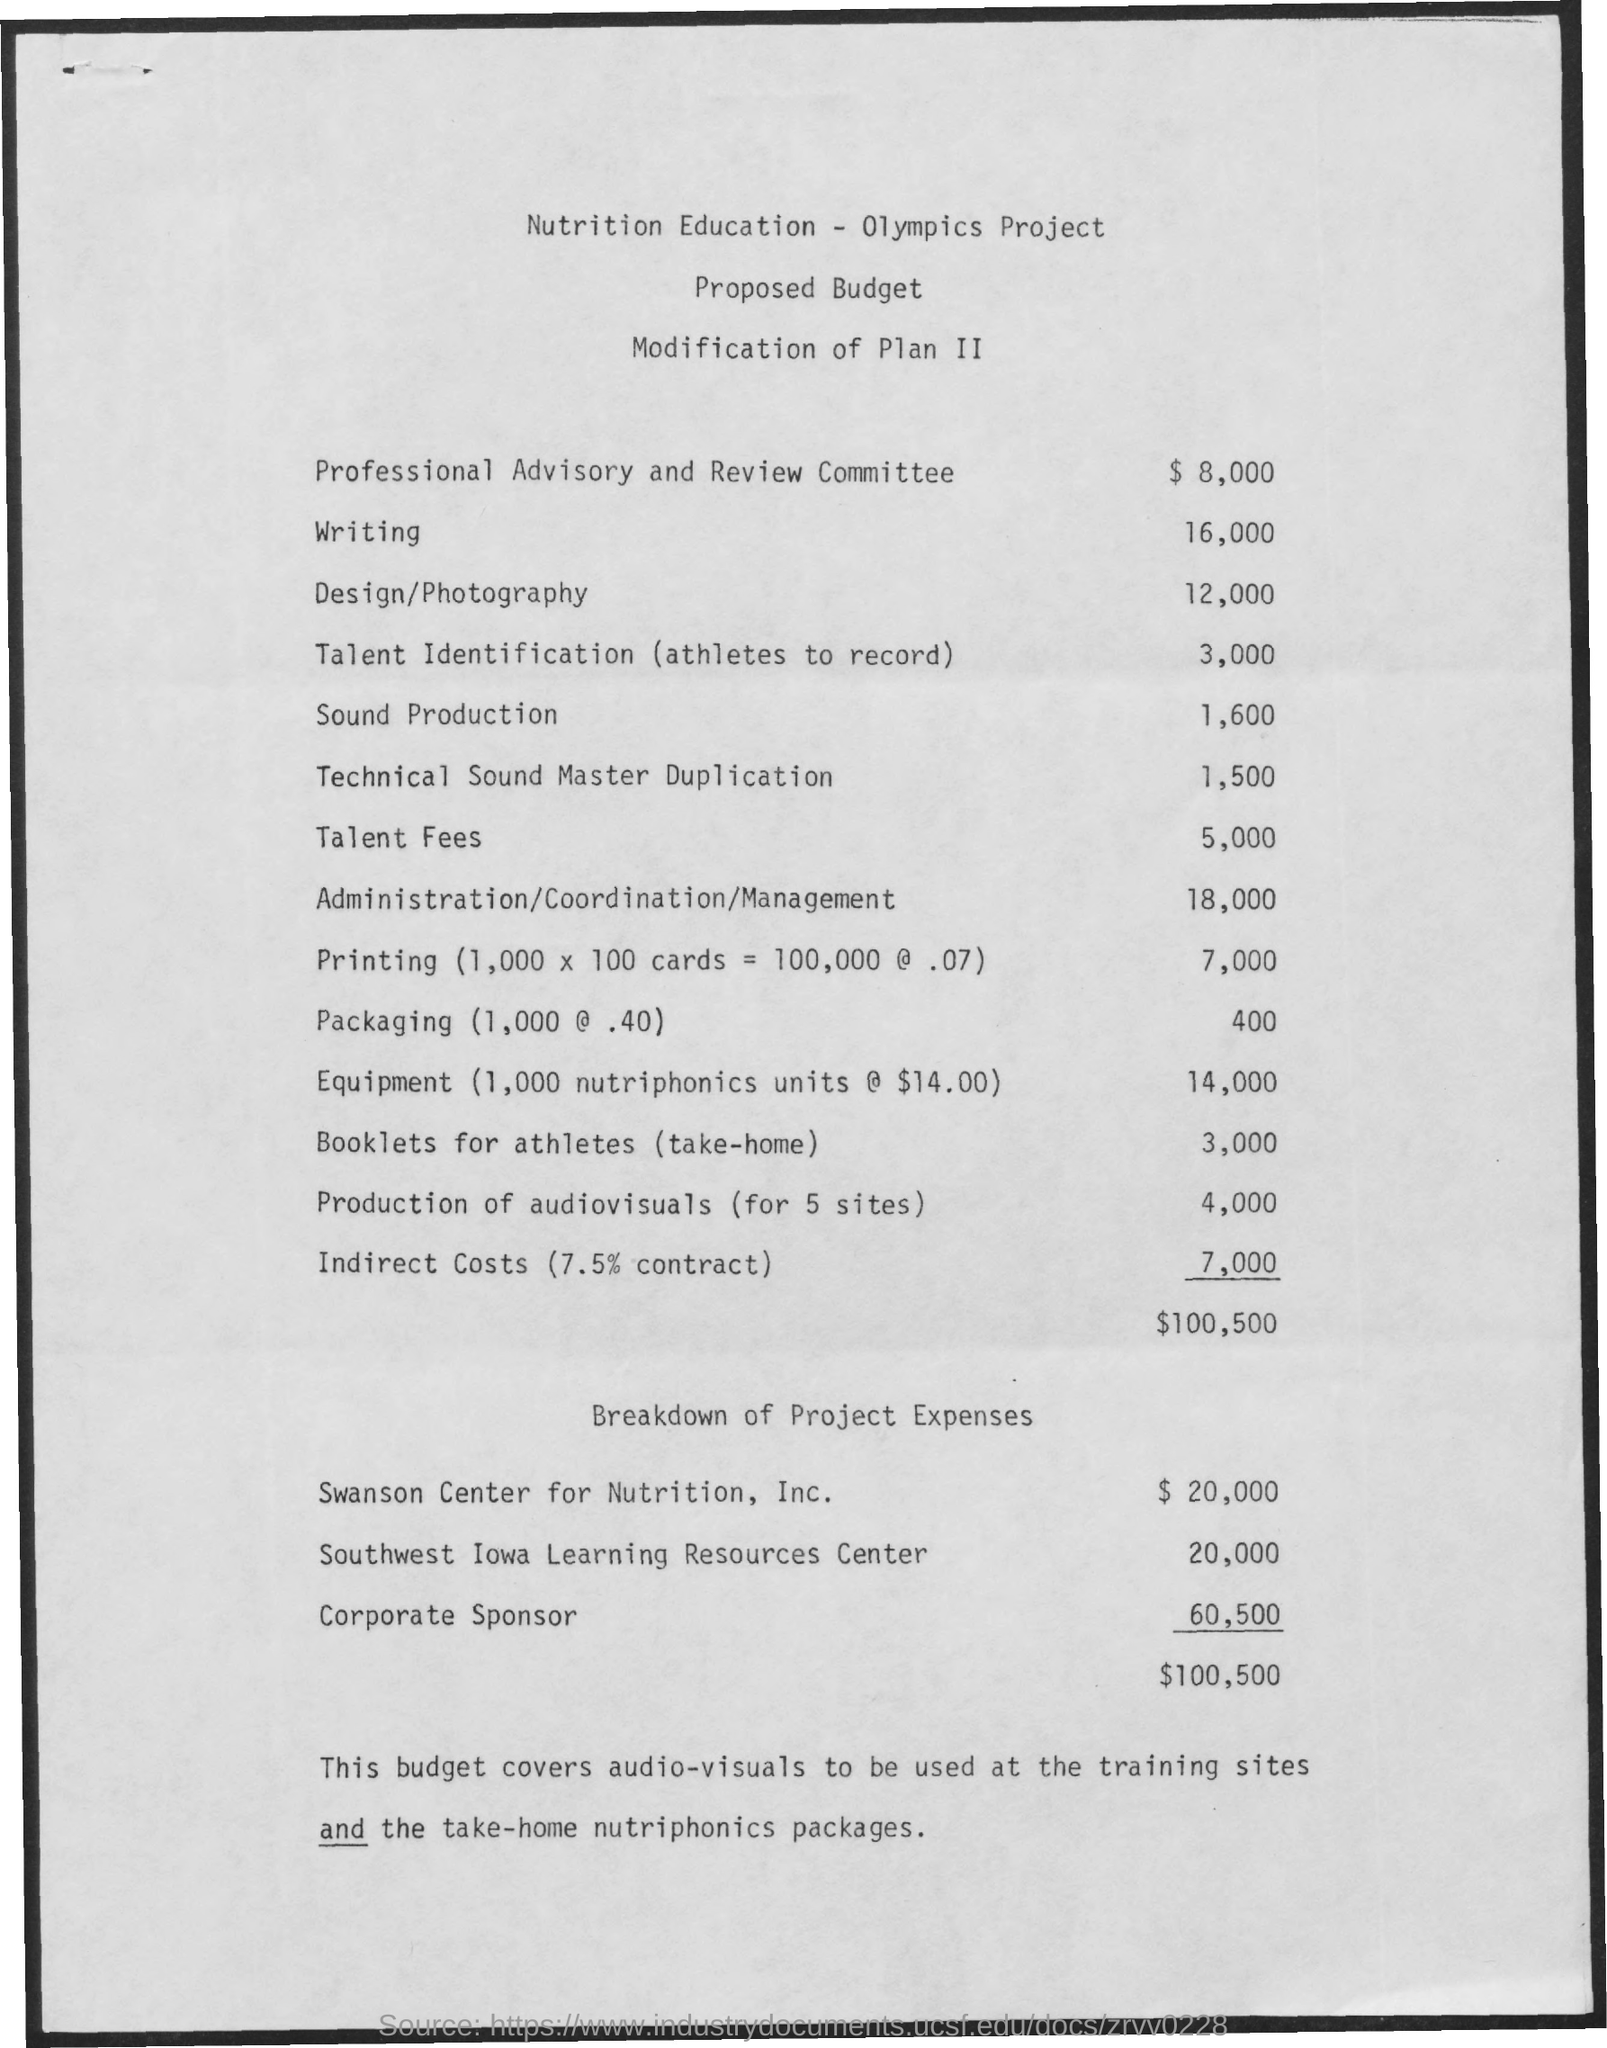Give some essential details in this illustration. The amount of expenses mentioned for corporate sponsor is 60,500. The amount mentioned for the Southwest Iowa Learning Resources Center is $20,000. The budget for writing is mentioned to be 16,000. The amount mentioned for indirect costs is 7,000. The budget for the professional advisory and review committee is $8,000. 